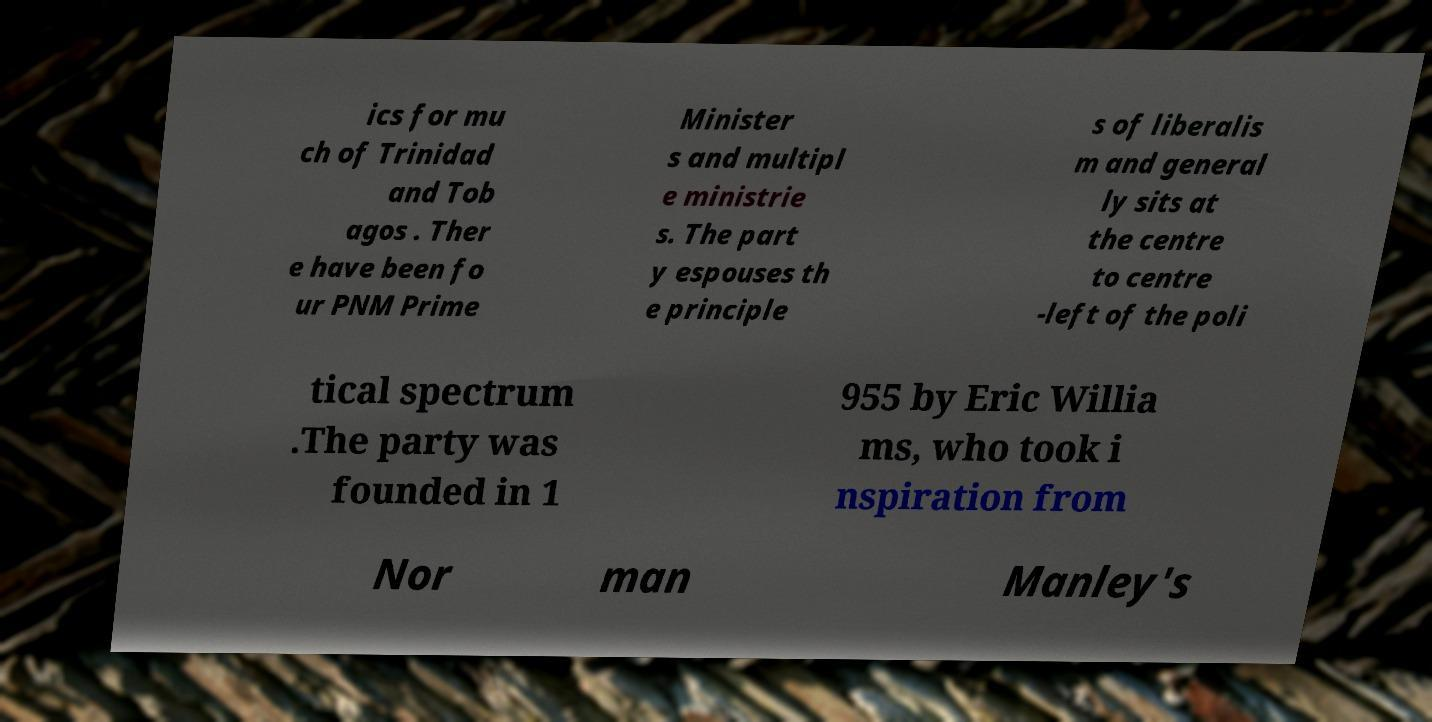Could you extract and type out the text from this image? ics for mu ch of Trinidad and Tob agos . Ther e have been fo ur PNM Prime Minister s and multipl e ministrie s. The part y espouses th e principle s of liberalis m and general ly sits at the centre to centre -left of the poli tical spectrum .The party was founded in 1 955 by Eric Willia ms, who took i nspiration from Nor man Manley's 